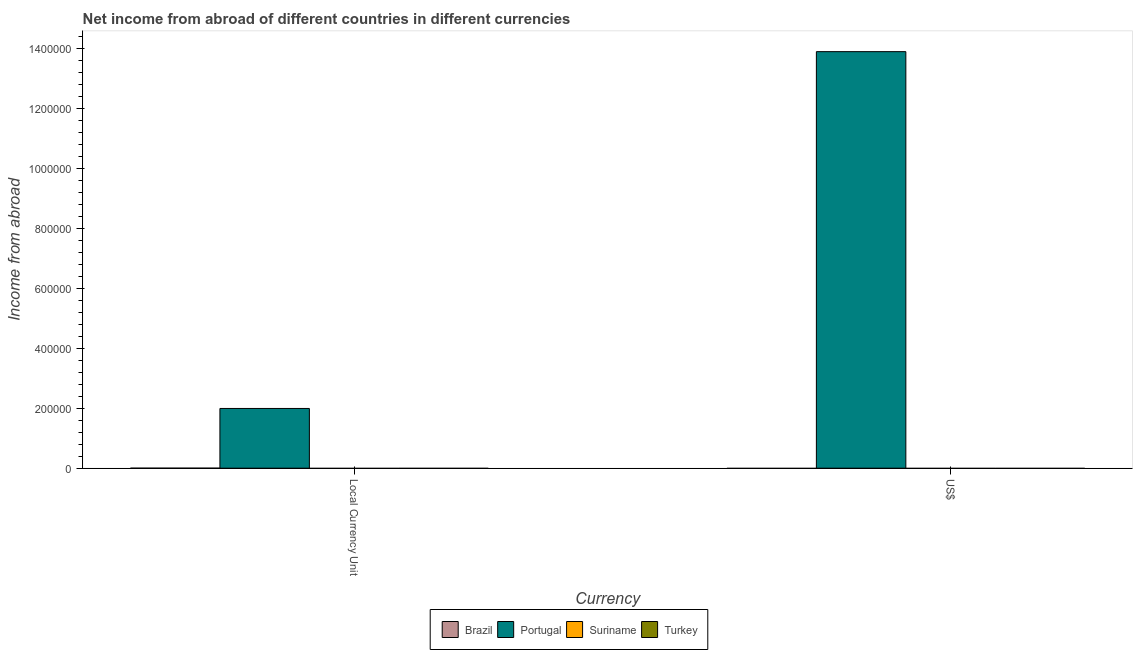What is the label of the 1st group of bars from the left?
Your answer should be very brief. Local Currency Unit. What is the income from abroad in constant 2005 us$ in Portugal?
Provide a short and direct response. 1.99e+05. Across all countries, what is the maximum income from abroad in us$?
Give a very brief answer. 1.39e+06. Across all countries, what is the minimum income from abroad in us$?
Provide a short and direct response. 0. What is the total income from abroad in constant 2005 us$ in the graph?
Your response must be concise. 1.99e+05. What is the average income from abroad in us$ per country?
Offer a terse response. 3.47e+05. What is the difference between the income from abroad in us$ and income from abroad in constant 2005 us$ in Portugal?
Give a very brief answer. 1.19e+06. In how many countries, is the income from abroad in constant 2005 us$ greater than 880000 units?
Provide a short and direct response. 0. How many bars are there?
Offer a very short reply. 2. Are all the bars in the graph horizontal?
Offer a terse response. No. How many countries are there in the graph?
Provide a short and direct response. 4. Does the graph contain any zero values?
Your response must be concise. Yes. How many legend labels are there?
Your answer should be compact. 4. What is the title of the graph?
Make the answer very short. Net income from abroad of different countries in different currencies. Does "Mauritius" appear as one of the legend labels in the graph?
Your answer should be very brief. No. What is the label or title of the X-axis?
Offer a terse response. Currency. What is the label or title of the Y-axis?
Offer a terse response. Income from abroad. What is the Income from abroad in Brazil in Local Currency Unit?
Provide a short and direct response. 0. What is the Income from abroad of Portugal in Local Currency Unit?
Offer a very short reply. 1.99e+05. What is the Income from abroad in Brazil in US$?
Offer a terse response. 0. What is the Income from abroad in Portugal in US$?
Provide a short and direct response. 1.39e+06. What is the Income from abroad in Suriname in US$?
Your answer should be compact. 0. What is the Income from abroad in Turkey in US$?
Your answer should be very brief. 0. Across all Currency, what is the maximum Income from abroad in Portugal?
Make the answer very short. 1.39e+06. Across all Currency, what is the minimum Income from abroad of Portugal?
Your answer should be very brief. 1.99e+05. What is the total Income from abroad of Brazil in the graph?
Keep it short and to the point. 0. What is the total Income from abroad in Portugal in the graph?
Offer a terse response. 1.59e+06. What is the total Income from abroad of Suriname in the graph?
Your answer should be very brief. 0. What is the difference between the Income from abroad of Portugal in Local Currency Unit and that in US$?
Give a very brief answer. -1.19e+06. What is the average Income from abroad in Brazil per Currency?
Ensure brevity in your answer.  0. What is the average Income from abroad in Portugal per Currency?
Give a very brief answer. 7.94e+05. What is the average Income from abroad of Suriname per Currency?
Make the answer very short. 0. What is the average Income from abroad in Turkey per Currency?
Your answer should be very brief. 0. What is the ratio of the Income from abroad in Portugal in Local Currency Unit to that in US$?
Keep it short and to the point. 0.14. What is the difference between the highest and the second highest Income from abroad of Portugal?
Offer a terse response. 1.19e+06. What is the difference between the highest and the lowest Income from abroad in Portugal?
Ensure brevity in your answer.  1.19e+06. 